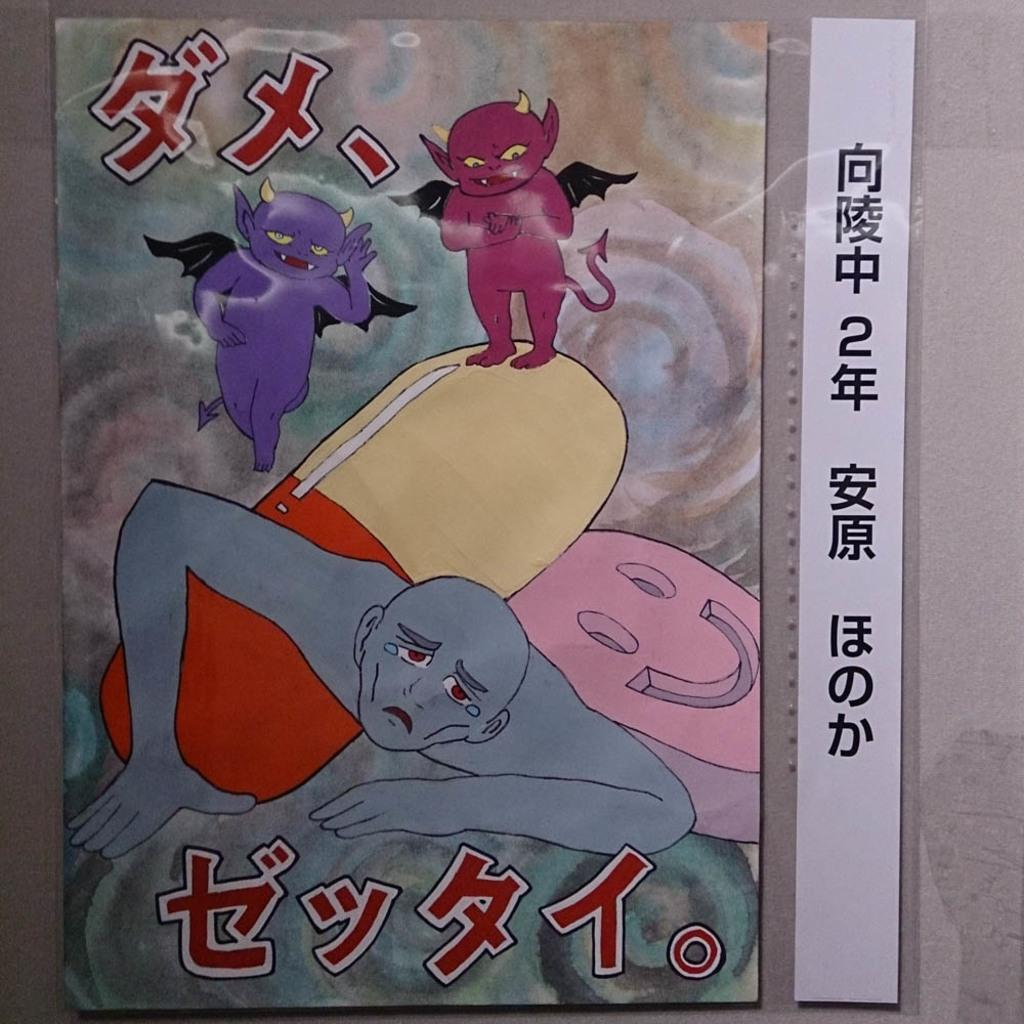What is featured on the poster in the image? The poster contains cartoon pictures. Is there any text on the poster? Yes, there is text on the poster. What can be seen in the background of the image? There is a wall in the background of the image. What type of advertisement is being displayed on the scale in the image? There is no scale or advertisement present in the image. 